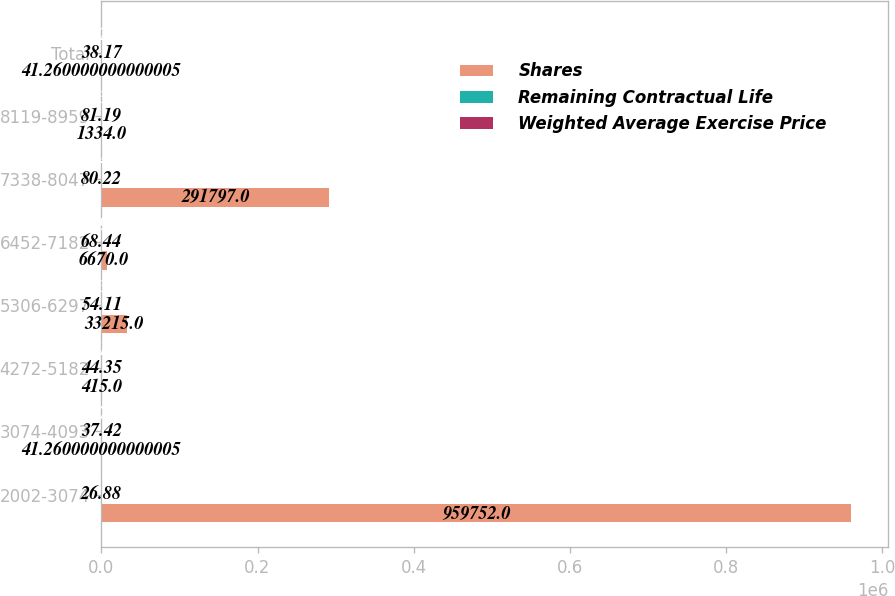Convert chart. <chart><loc_0><loc_0><loc_500><loc_500><stacked_bar_chart><ecel><fcel>2002-3074<fcel>3074-4093<fcel>4272-5182<fcel>5306-6297<fcel>6452-7182<fcel>7338-8047<fcel>8119-8959<fcel>Total<nl><fcel>Shares<fcel>959752<fcel>41.26<fcel>415<fcel>33215<fcel>6670<fcel>291797<fcel>1334<fcel>41.26<nl><fcel>Remaining Contractual Life<fcel>26.88<fcel>37.42<fcel>44.35<fcel>54.11<fcel>68.44<fcel>80.22<fcel>81.19<fcel>38.17<nl><fcel>Weighted Average Exercise Price<fcel>1.5<fcel>3.79<fcel>2.16<fcel>3.34<fcel>4.99<fcel>3.44<fcel>5.33<fcel>3.25<nl></chart> 